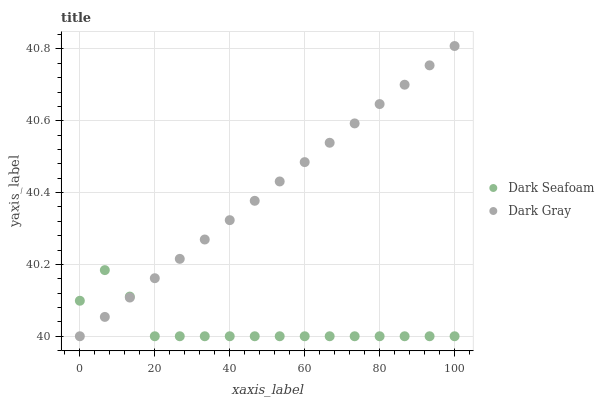Does Dark Seafoam have the minimum area under the curve?
Answer yes or no. Yes. Does Dark Gray have the maximum area under the curve?
Answer yes or no. Yes. Does Dark Seafoam have the maximum area under the curve?
Answer yes or no. No. Is Dark Gray the smoothest?
Answer yes or no. Yes. Is Dark Seafoam the roughest?
Answer yes or no. Yes. Is Dark Seafoam the smoothest?
Answer yes or no. No. Does Dark Gray have the lowest value?
Answer yes or no. Yes. Does Dark Gray have the highest value?
Answer yes or no. Yes. Does Dark Seafoam have the highest value?
Answer yes or no. No. Does Dark Seafoam intersect Dark Gray?
Answer yes or no. Yes. Is Dark Seafoam less than Dark Gray?
Answer yes or no. No. Is Dark Seafoam greater than Dark Gray?
Answer yes or no. No. 